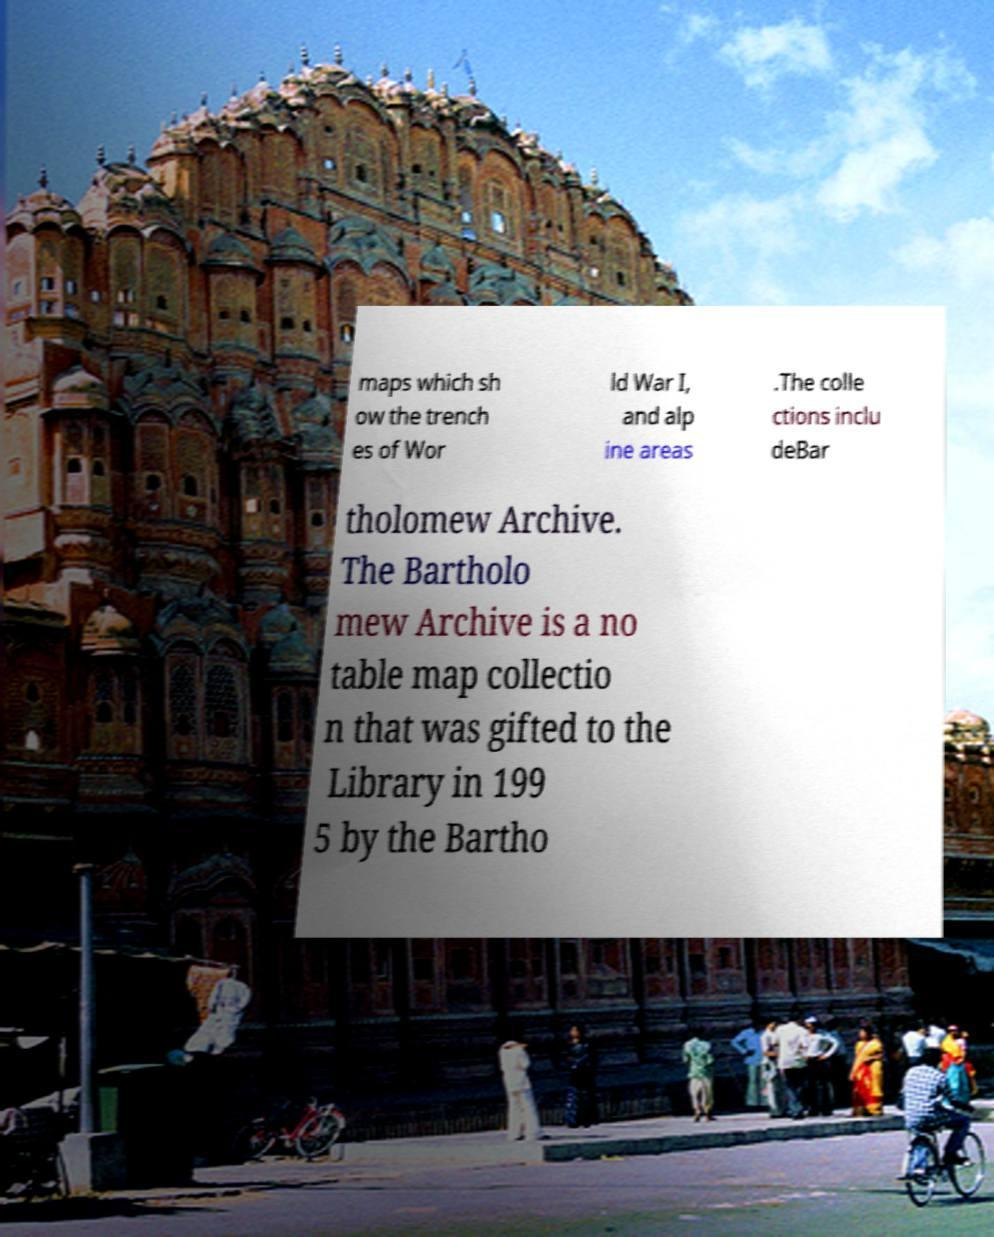There's text embedded in this image that I need extracted. Can you transcribe it verbatim? maps which sh ow the trench es of Wor ld War I, and alp ine areas .The colle ctions inclu deBar tholomew Archive. The Bartholo mew Archive is a no table map collectio n that was gifted to the Library in 199 5 by the Bartho 